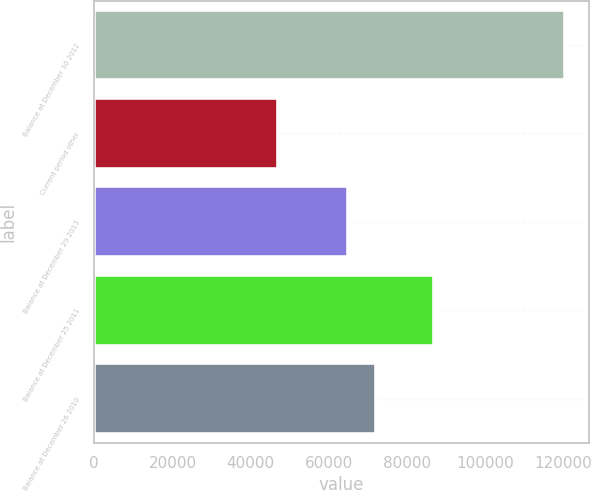Convert chart. <chart><loc_0><loc_0><loc_500><loc_500><bar_chart><fcel>Balance at December 30 2012<fcel>Current period other<fcel>Balance at December 29 2013<fcel>Balance at December 25 2011<fcel>Balance at December 26 2010<nl><fcel>120422<fcel>47081<fcel>64841<fcel>86822<fcel>72175.1<nl></chart> 